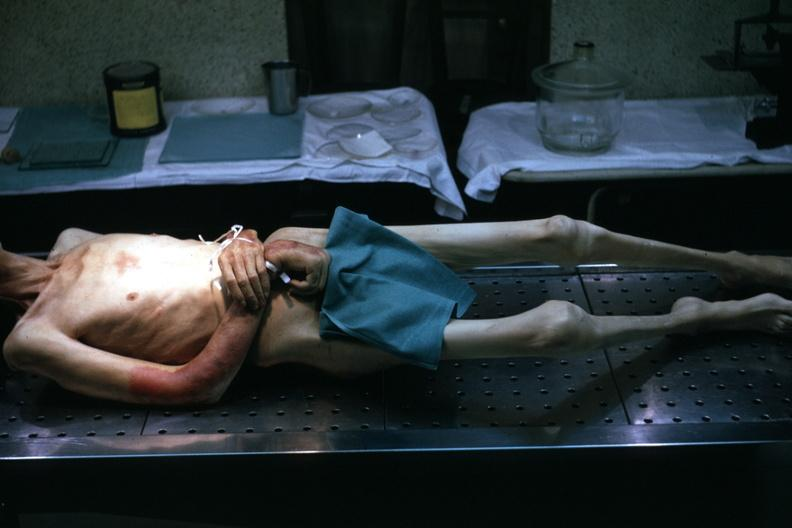what is good example tastefully shown with face out of picture and genitalia covered?
Answer the question using a single word or phrase. Muscle atrophy striking 